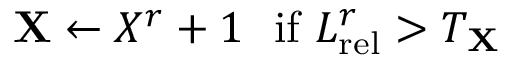<formula> <loc_0><loc_0><loc_500><loc_500>X \leftarrow X ^ { r } + 1 \ \ i f \ L _ { r e l } ^ { r } > T _ { X }</formula> 